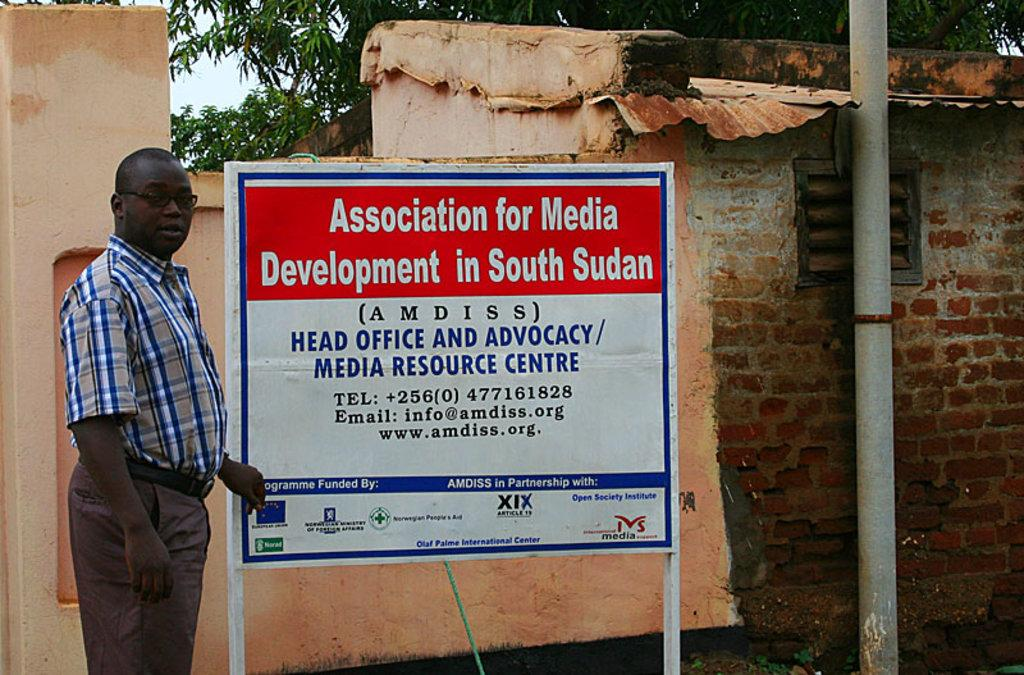What is the person in the image doing near the notice board? The person is standing near a notice board in the image. What type of structure is depicted in the image? The image seems to depict a house. Can you describe any specific features of the house? There is a pipe visible in the image. What can be seen in the background of the image? There are trees and the sky visible in the background of the image. What idea does the person have after reading the notice on the board? There is no indication in the image of what the person might be thinking or what ideas they may have. 